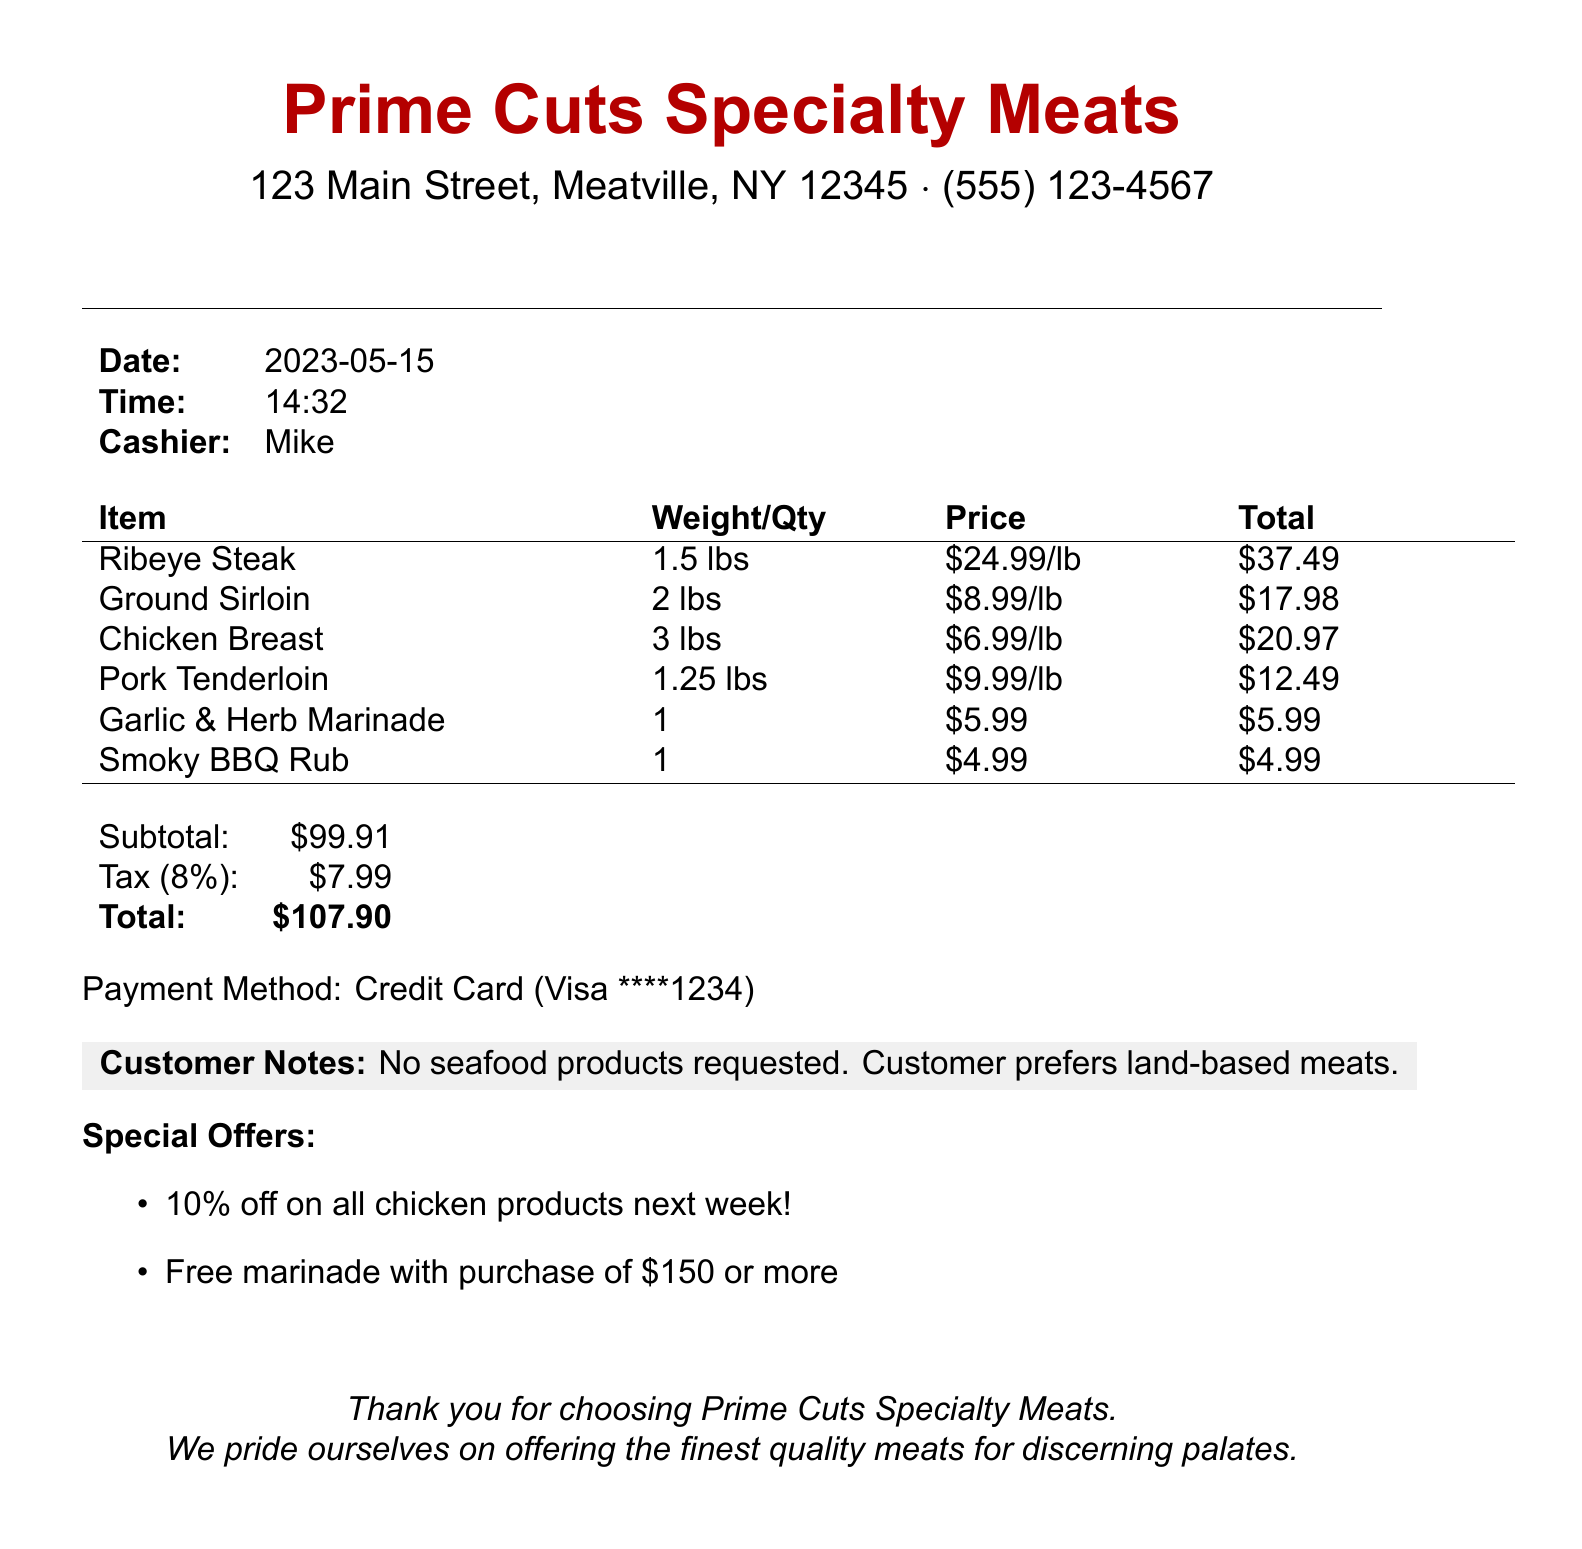What is the name of the butcher shop? The name of the butcher shop is listed at the top of the document.
Answer: Prime Cuts Specialty Meats What is the total amount due? The total amount due is calculated at the end of the receipt, including subtotal and tax.
Answer: $107.90 Who was the cashier? The name of the cashier is mentioned in the receipt details.
Answer: Mike How much did the Ribeye Steak weigh? The weight of the Ribeye Steak is specified next to the item on the receipt.
Answer: 1.5 lbs What is the customer note regarding seafood? The customer note specifies preferences and restrictions related to seafood products.
Answer: No seafood products requested. Customer prefers land-based meats What is the tax rate applied? The tax rate is indicated in the calculations on the receipt.
Answer: 8% How much did the Garlic & Herb Marinade cost? The price for the Garlic & Herb Marinade is shown under the item section of the receipt.
Answer: $5.99 What type of payment method was used? The payment method is stated at the end of the document.
Answer: Credit Card What special offer is available for chicken products next week? The document contains a special offer related to chicken products.
Answer: 10% off on all chicken products next week! 